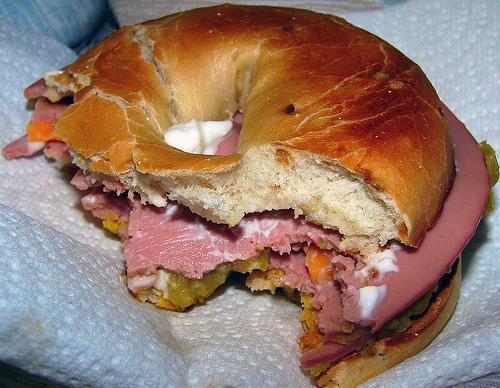How many sandwiches are in the photo?
Give a very brief answer. 1. 